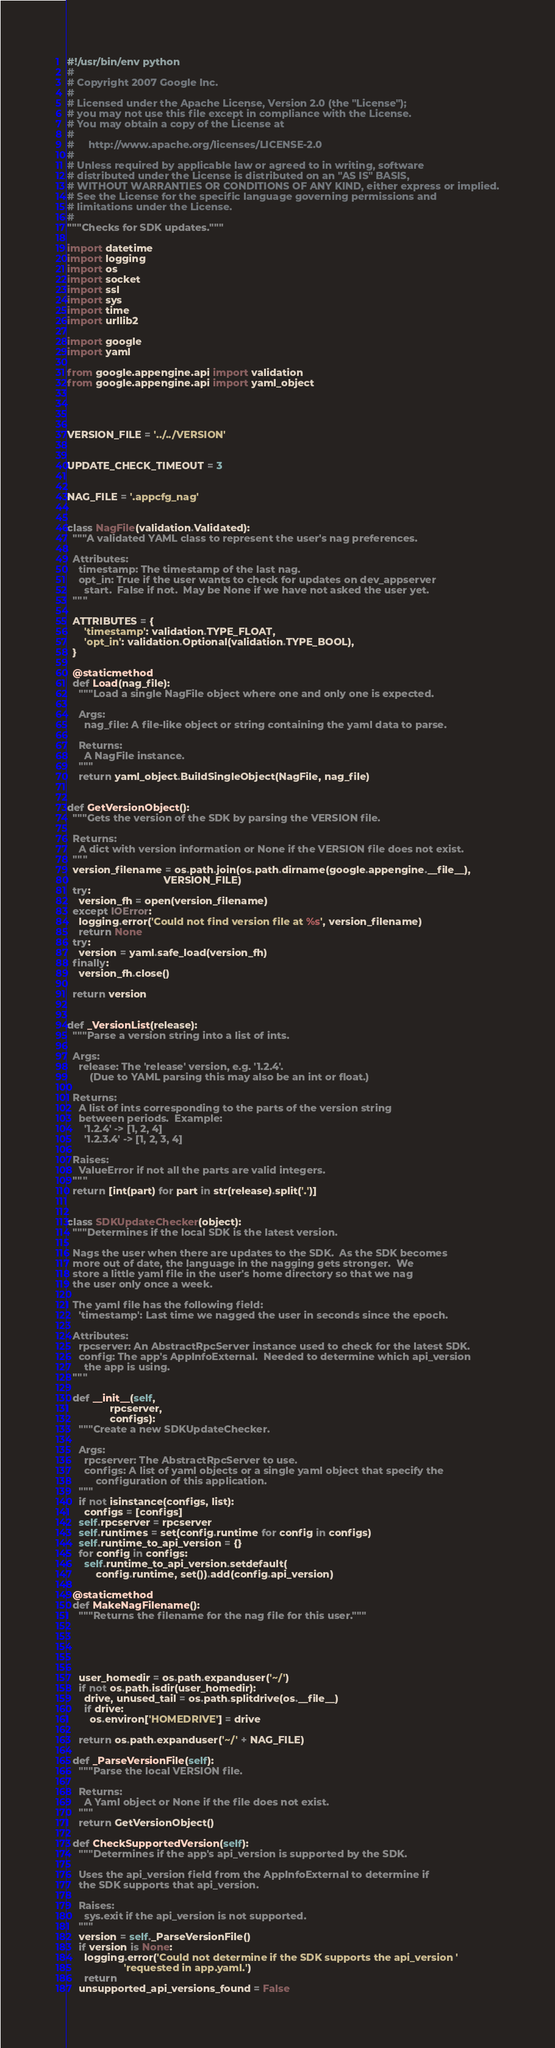Convert code to text. <code><loc_0><loc_0><loc_500><loc_500><_Python_>#!/usr/bin/env python
#
# Copyright 2007 Google Inc.
#
# Licensed under the Apache License, Version 2.0 (the "License");
# you may not use this file except in compliance with the License.
# You may obtain a copy of the License at
#
#     http://www.apache.org/licenses/LICENSE-2.0
#
# Unless required by applicable law or agreed to in writing, software
# distributed under the License is distributed on an "AS IS" BASIS,
# WITHOUT WARRANTIES OR CONDITIONS OF ANY KIND, either express or implied.
# See the License for the specific language governing permissions and
# limitations under the License.
#
"""Checks for SDK updates."""

import datetime
import logging
import os
import socket
import ssl
import sys
import time
import urllib2

import google
import yaml

from google.appengine.api import validation
from google.appengine.api import yaml_object




VERSION_FILE = '../../VERSION'


UPDATE_CHECK_TIMEOUT = 3


NAG_FILE = '.appcfg_nag'


class NagFile(validation.Validated):
  """A validated YAML class to represent the user's nag preferences.

  Attributes:
    timestamp: The timestamp of the last nag.
    opt_in: True if the user wants to check for updates on dev_appserver
      start.  False if not.  May be None if we have not asked the user yet.
  """

  ATTRIBUTES = {
      'timestamp': validation.TYPE_FLOAT,
      'opt_in': validation.Optional(validation.TYPE_BOOL),
  }

  @staticmethod
  def Load(nag_file):
    """Load a single NagFile object where one and only one is expected.

    Args:
      nag_file: A file-like object or string containing the yaml data to parse.

    Returns:
      A NagFile instance.
    """
    return yaml_object.BuildSingleObject(NagFile, nag_file)


def GetVersionObject():
  """Gets the version of the SDK by parsing the VERSION file.

  Returns:
    A dict with version information or None if the VERSION file does not exist.
  """
  version_filename = os.path.join(os.path.dirname(google.appengine.__file__),
                                  VERSION_FILE)
  try:
    version_fh = open(version_filename)
  except IOError:
    logging.error('Could not find version file at %s', version_filename)
    return None
  try:
    version = yaml.safe_load(version_fh)
  finally:
    version_fh.close()

  return version


def _VersionList(release):
  """Parse a version string into a list of ints.

  Args:
    release: The 'release' version, e.g. '1.2.4'.
        (Due to YAML parsing this may also be an int or float.)

  Returns:
    A list of ints corresponding to the parts of the version string
    between periods.  Example:
      '1.2.4' -> [1, 2, 4]
      '1.2.3.4' -> [1, 2, 3, 4]

  Raises:
    ValueError if not all the parts are valid integers.
  """
  return [int(part) for part in str(release).split('.')]


class SDKUpdateChecker(object):
  """Determines if the local SDK is the latest version.

  Nags the user when there are updates to the SDK.  As the SDK becomes
  more out of date, the language in the nagging gets stronger.  We
  store a little yaml file in the user's home directory so that we nag
  the user only once a week.

  The yaml file has the following field:
    'timestamp': Last time we nagged the user in seconds since the epoch.

  Attributes:
    rpcserver: An AbstractRpcServer instance used to check for the latest SDK.
    config: The app's AppInfoExternal.  Needed to determine which api_version
      the app is using.
  """

  def __init__(self,
               rpcserver,
               configs):
    """Create a new SDKUpdateChecker.

    Args:
      rpcserver: The AbstractRpcServer to use.
      configs: A list of yaml objects or a single yaml object that specify the
          configuration of this application.
    """
    if not isinstance(configs, list):
      configs = [configs]
    self.rpcserver = rpcserver
    self.runtimes = set(config.runtime for config in configs)
    self.runtime_to_api_version = {}
    for config in configs:
      self.runtime_to_api_version.setdefault(
          config.runtime, set()).add(config.api_version)

  @staticmethod
  def MakeNagFilename():
    """Returns the filename for the nag file for this user."""





    user_homedir = os.path.expanduser('~/')
    if not os.path.isdir(user_homedir):
      drive, unused_tail = os.path.splitdrive(os.__file__)
      if drive:
        os.environ['HOMEDRIVE'] = drive

    return os.path.expanduser('~/' + NAG_FILE)

  def _ParseVersionFile(self):
    """Parse the local VERSION file.

    Returns:
      A Yaml object or None if the file does not exist.
    """
    return GetVersionObject()

  def CheckSupportedVersion(self):
    """Determines if the app's api_version is supported by the SDK.

    Uses the api_version field from the AppInfoExternal to determine if
    the SDK supports that api_version.

    Raises:
      sys.exit if the api_version is not supported.
    """
    version = self._ParseVersionFile()
    if version is None:
      logging.error('Could not determine if the SDK supports the api_version '
                    'requested in app.yaml.')
      return
    unsupported_api_versions_found = False</code> 